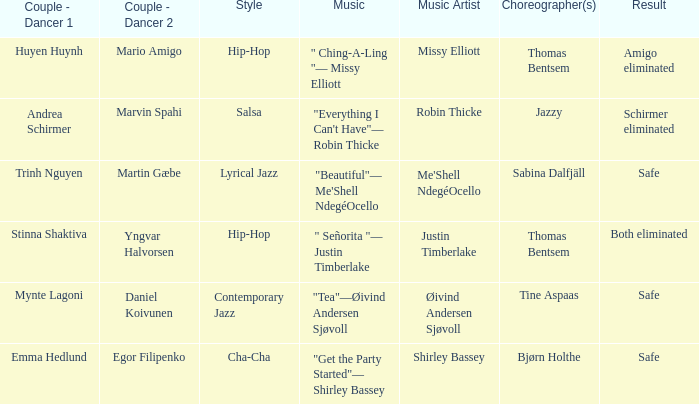What is the music for choreographer sabina dalfjäll? "Beautiful"— Me'Shell NdegéOcello. Can you parse all the data within this table? {'header': ['Couple - Dancer 1', 'Couple - Dancer 2', 'Style', 'Music', 'Music Artist', 'Choreographer(s)', 'Result'], 'rows': [['Huyen Huynh', 'Mario Amigo', 'Hip-Hop', '" Ching-A-Ling "— Missy Elliott', 'Missy Elliott', 'Thomas Bentsem', 'Amigo eliminated'], ['Andrea Schirmer', 'Marvin Spahi', 'Salsa', '"Everything I Can\'t Have"— Robin Thicke', 'Robin Thicke', 'Jazzy', 'Schirmer eliminated'], ['Trinh Nguyen', 'Martin Gæbe', 'Lyrical Jazz', '"Beautiful"— Me\'Shell NdegéOcello', "Me'Shell NdegéOcello", 'Sabina Dalfjäll', 'Safe'], ['Stinna Shaktiva', 'Yngvar Halvorsen', 'Hip-Hop', '" Señorita "— Justin Timberlake', 'Justin Timberlake', 'Thomas Bentsem', 'Both eliminated'], ['Mynte Lagoni', 'Daniel Koivunen', 'Contemporary Jazz', '"Tea"—Øivind Andersen Sjøvoll', 'Øivind Andersen Sjøvoll', 'Tine Aspaas', 'Safe'], ['Emma Hedlund', 'Egor Filipenko', 'Cha-Cha', '"Get the Party Started"— Shirley Bassey', 'Shirley Bassey', 'Bjørn Holthe', 'Safe']]} 